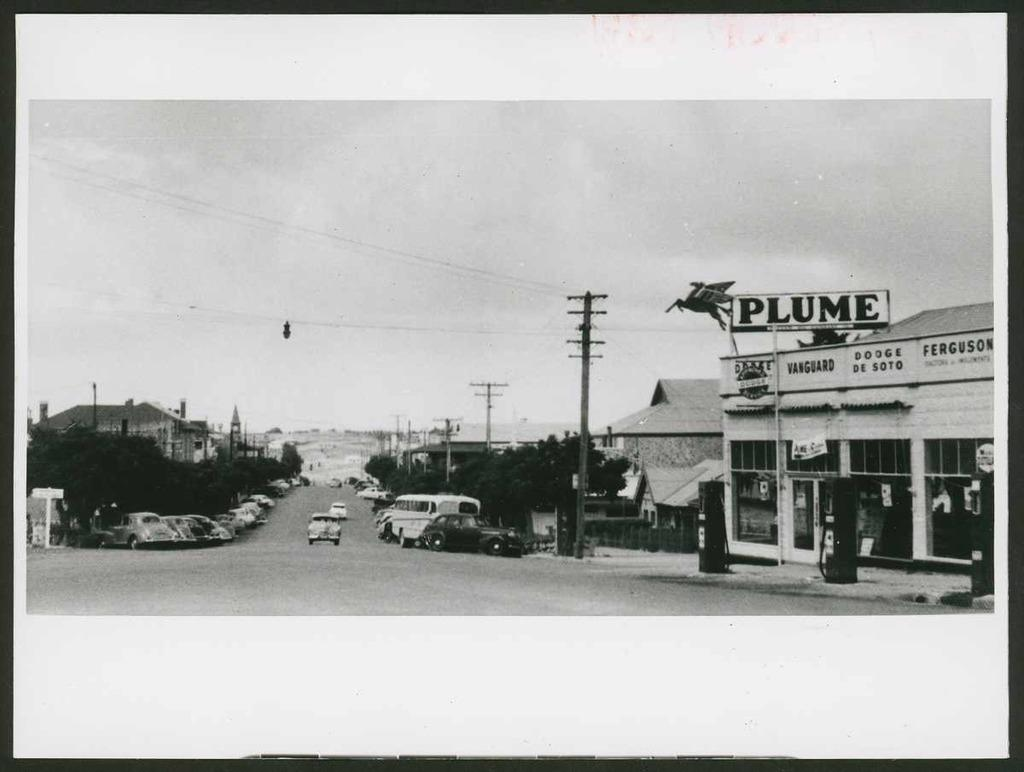<image>
Share a concise interpretation of the image provided. A black and white picture of a place called Plume from the streetview is framed. 